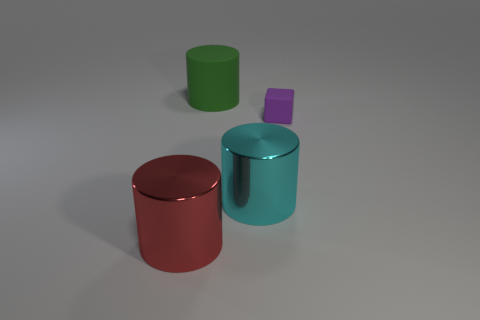Subtract 1 cylinders. How many cylinders are left? 2 Add 2 large matte objects. How many objects exist? 6 Subtract all cylinders. How many objects are left? 1 Add 1 large shiny balls. How many large shiny balls exist? 1 Subtract 1 purple cubes. How many objects are left? 3 Subtract all gray things. Subtract all small things. How many objects are left? 3 Add 4 purple objects. How many purple objects are left? 5 